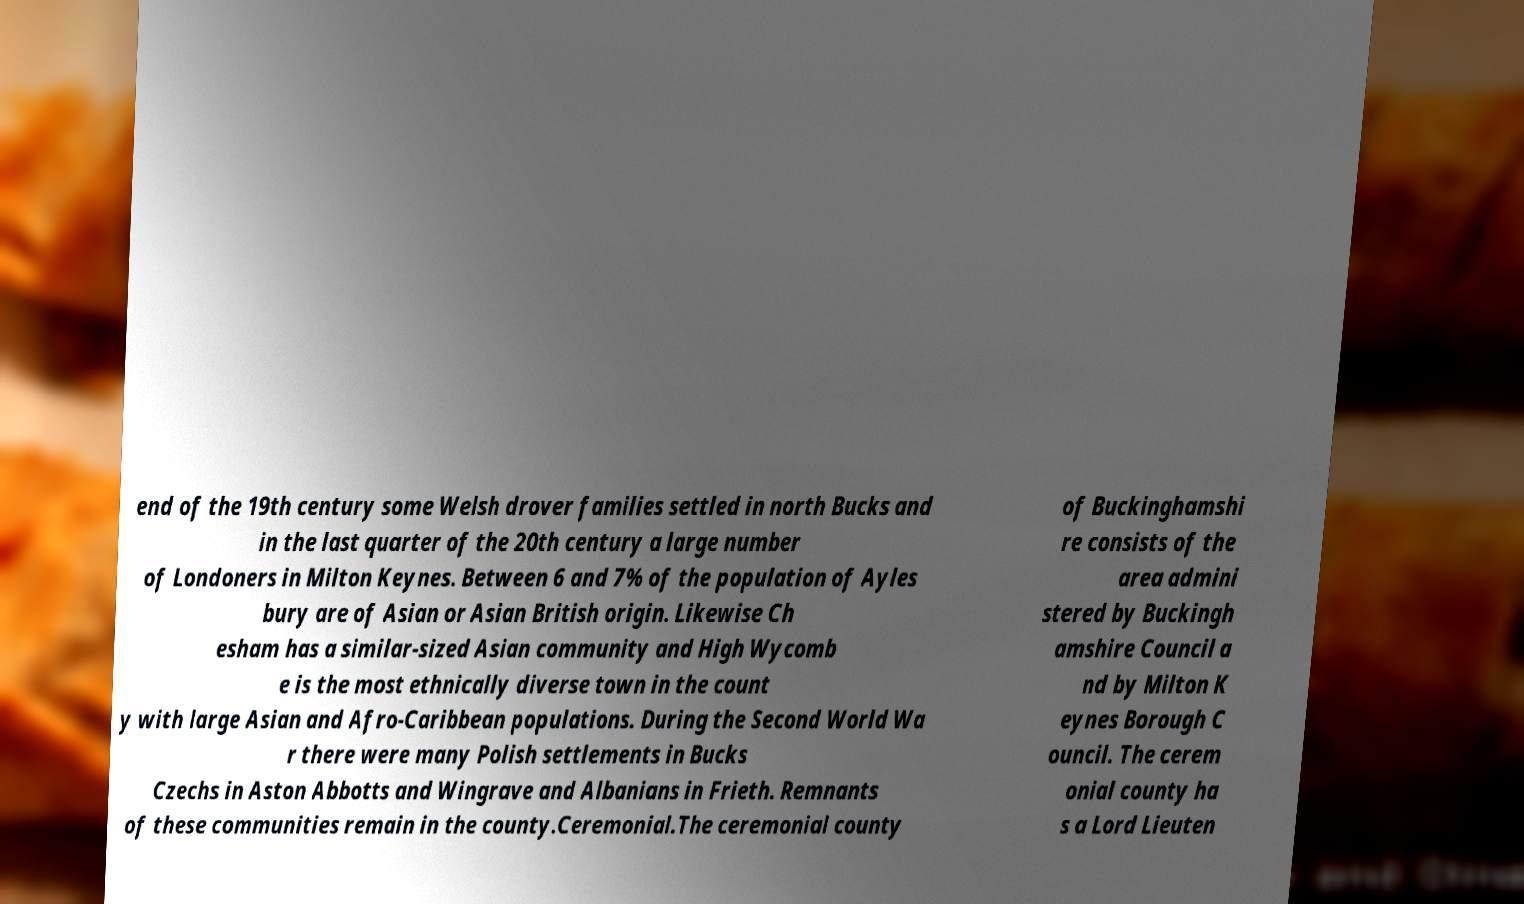There's text embedded in this image that I need extracted. Can you transcribe it verbatim? end of the 19th century some Welsh drover families settled in north Bucks and in the last quarter of the 20th century a large number of Londoners in Milton Keynes. Between 6 and 7% of the population of Ayles bury are of Asian or Asian British origin. Likewise Ch esham has a similar-sized Asian community and High Wycomb e is the most ethnically diverse town in the count y with large Asian and Afro-Caribbean populations. During the Second World Wa r there were many Polish settlements in Bucks Czechs in Aston Abbotts and Wingrave and Albanians in Frieth. Remnants of these communities remain in the county.Ceremonial.The ceremonial county of Buckinghamshi re consists of the area admini stered by Buckingh amshire Council a nd by Milton K eynes Borough C ouncil. The cerem onial county ha s a Lord Lieuten 